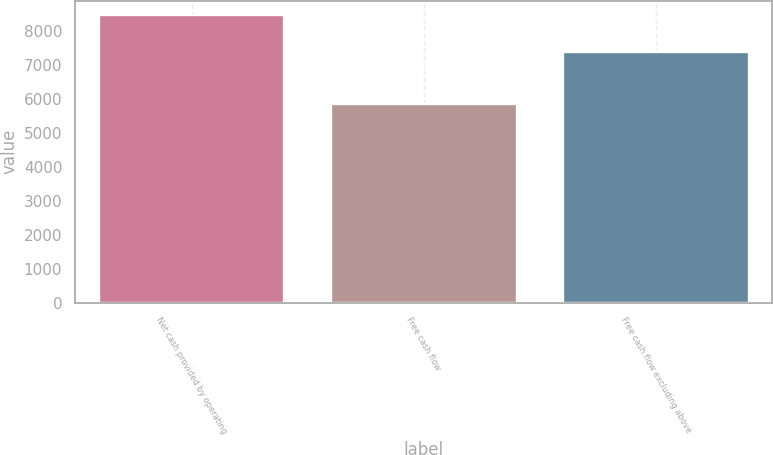<chart> <loc_0><loc_0><loc_500><loc_500><bar_chart><fcel>Net cash provided by operating<fcel>Free cash flow<fcel>Free cash flow excluding above<nl><fcel>8479<fcel>5860<fcel>7387<nl></chart> 